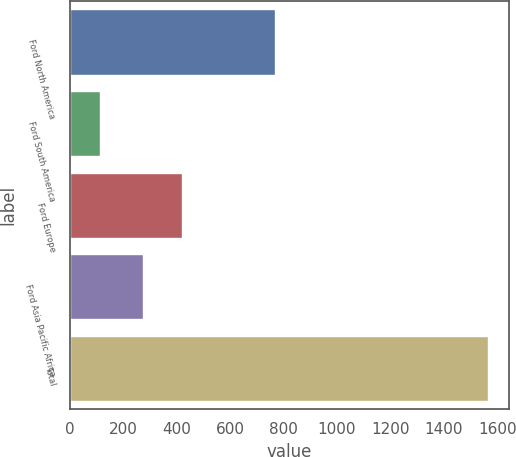Convert chart. <chart><loc_0><loc_0><loc_500><loc_500><bar_chart><fcel>Ford North America<fcel>Ford South America<fcel>Ford Europe<fcel>Ford Asia Pacific Africa<fcel>Total<nl><fcel>770<fcel>115<fcel>420<fcel>275<fcel>1565<nl></chart> 